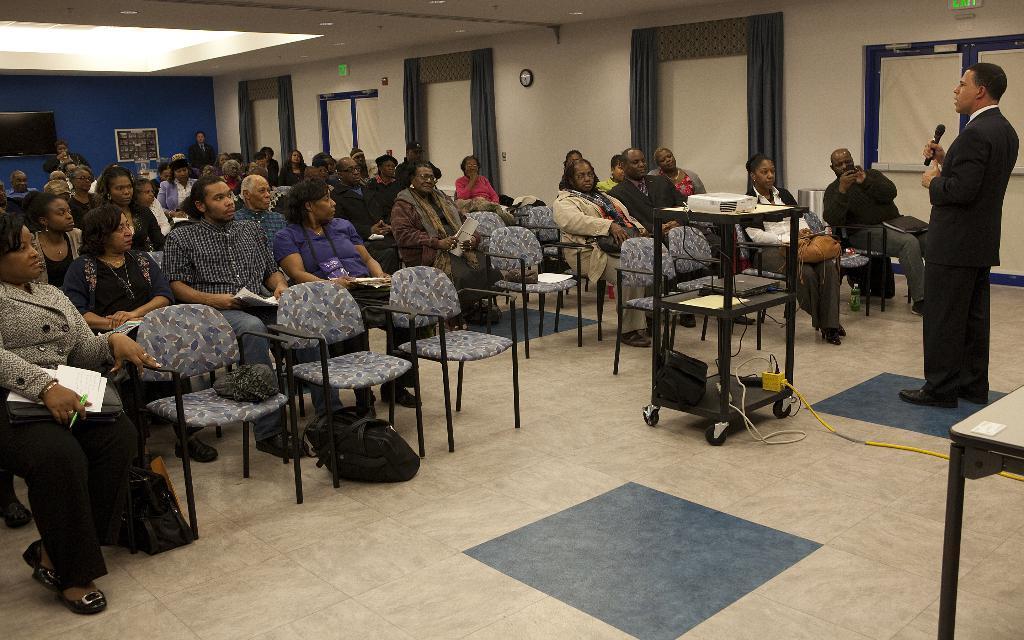Can you describe this image briefly? There is a group of people. They are sitting on a chair. We can see the background there is a curtain,wall. 